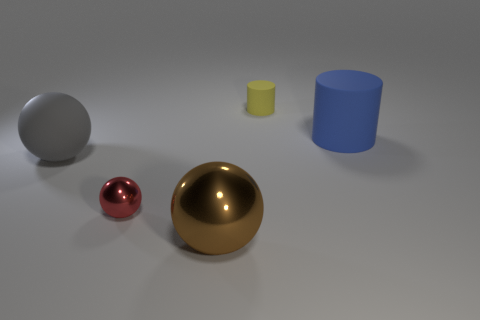Subtract all red metal spheres. How many spheres are left? 2 Subtract 1 spheres. How many spheres are left? 2 Subtract all yellow balls. Subtract all purple cylinders. How many balls are left? 3 Add 2 purple cubes. How many objects exist? 7 Subtract all cylinders. How many objects are left? 3 Subtract 1 brown balls. How many objects are left? 4 Subtract all gray matte balls. Subtract all big blue rubber things. How many objects are left? 3 Add 5 large gray rubber things. How many large gray rubber things are left? 6 Add 3 yellow objects. How many yellow objects exist? 4 